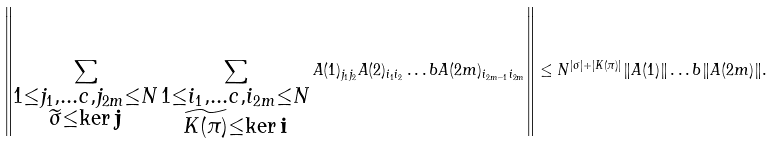<formula> <loc_0><loc_0><loc_500><loc_500>\left \| \sum _ { \substack { 1 \leq j _ { 1 } , \dots c , j _ { 2 m } \leq N \\ \widetilde { \sigma } \leq \ker \mathbf j } } \sum _ { \substack { 1 \leq i _ { 1 } , \dots c , i _ { 2 m } \leq N \\ \widetilde { K ( \pi ) } \leq \ker \mathbf i } } A ( 1 ) _ { j _ { 1 } j _ { 2 } } A ( 2 ) _ { i _ { 1 } i _ { 2 } } \dots b A ( 2 m ) _ { i _ { 2 m - 1 } i _ { 2 m } } \right \| \leq N ^ { | \sigma | + | K ( \pi ) | } \| A ( 1 ) \| \dots b \| A ( 2 m ) \| .</formula> 